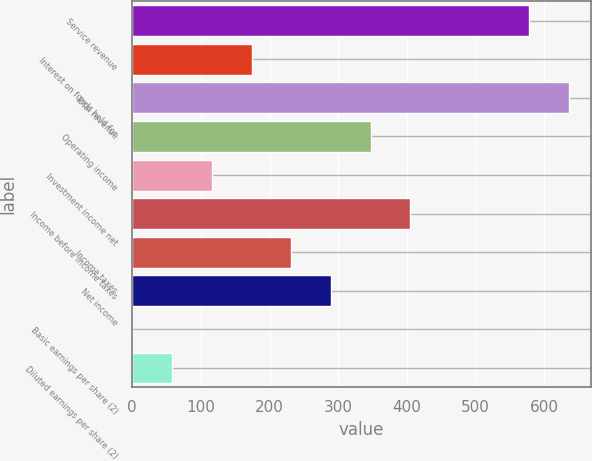<chart> <loc_0><loc_0><loc_500><loc_500><bar_chart><fcel>Service revenue<fcel>Interest on funds held for<fcel>Total revenue<fcel>Operating income<fcel>Investment income net<fcel>Income before income taxes<fcel>Income taxes<fcel>Net income<fcel>Basic earnings per share (2)<fcel>Diluted earnings per share (2)<nl><fcel>578.22<fcel>173.76<fcel>636<fcel>347.1<fcel>115.98<fcel>404.88<fcel>231.54<fcel>289.32<fcel>0.42<fcel>58.2<nl></chart> 